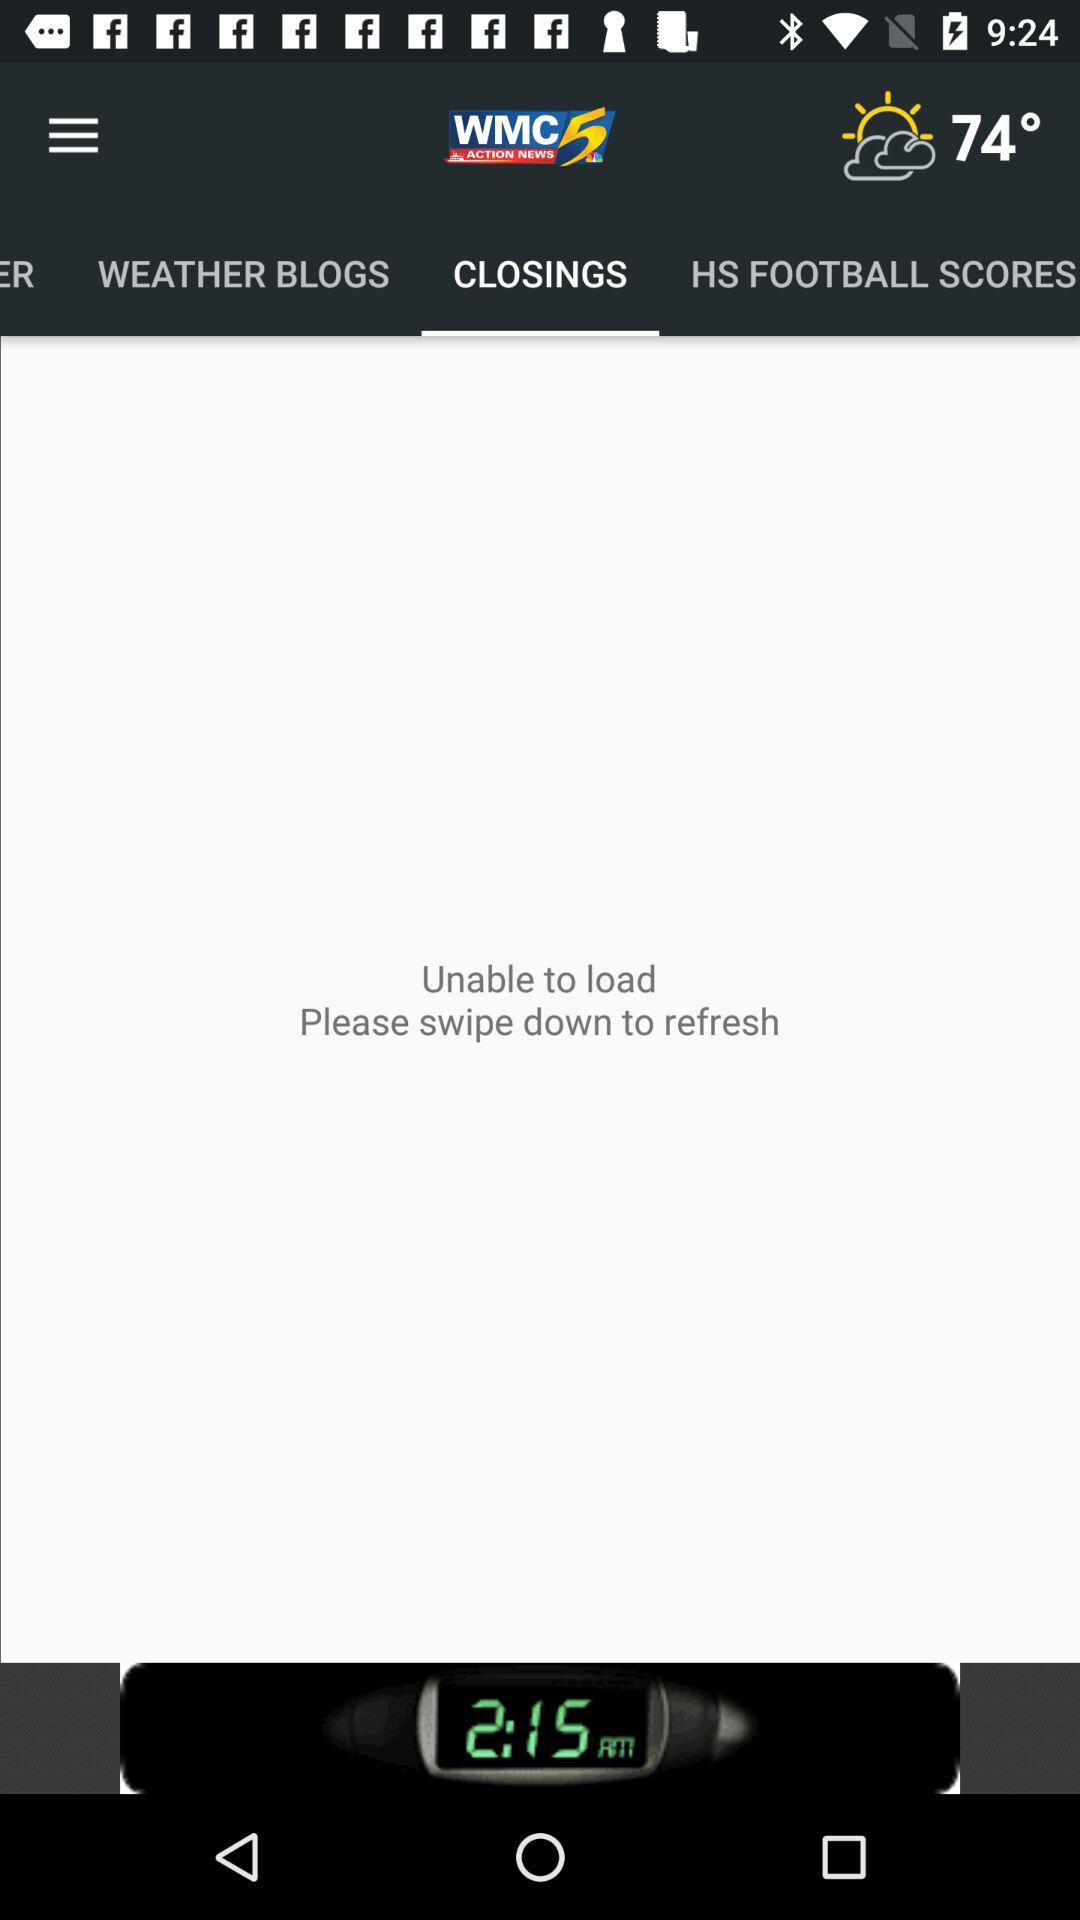What is the temperature shown on the screen? The temperature shown on the screen is 74°. 